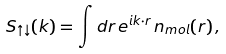Convert formula to latex. <formula><loc_0><loc_0><loc_500><loc_500>S _ { \uparrow \downarrow } ( k ) = \int d { r } \, e ^ { i { k \cdot r } } \, n _ { m o l } ( { r } ) \, ,</formula> 